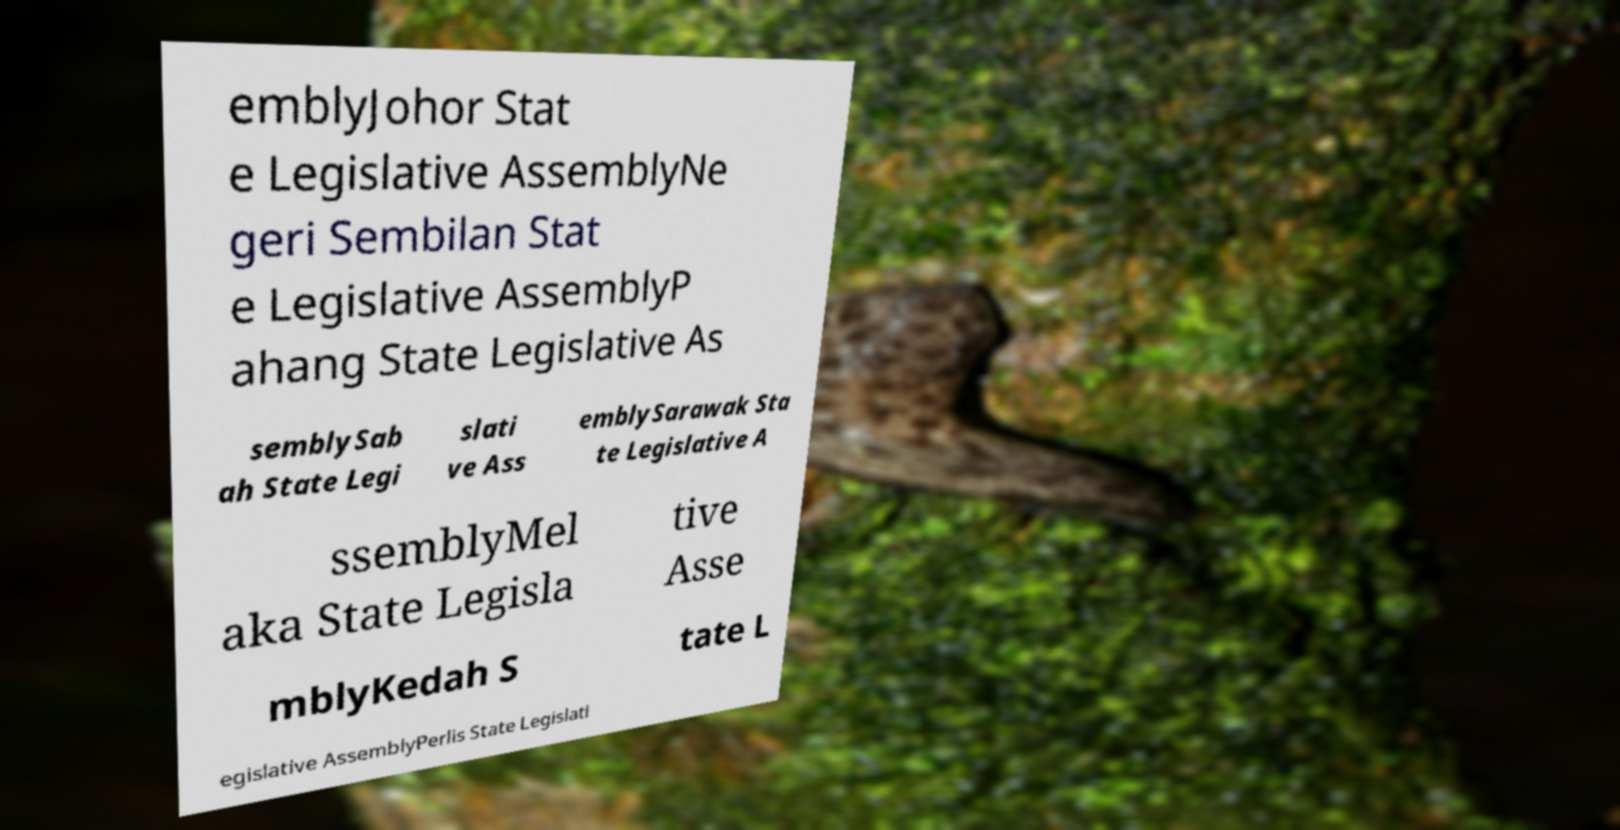Please read and relay the text visible in this image. What does it say? emblyJohor Stat e Legislative AssemblyNe geri Sembilan Stat e Legislative AssemblyP ahang State Legislative As semblySab ah State Legi slati ve Ass emblySarawak Sta te Legislative A ssemblyMel aka State Legisla tive Asse mblyKedah S tate L egislative AssemblyPerlis State Legislati 